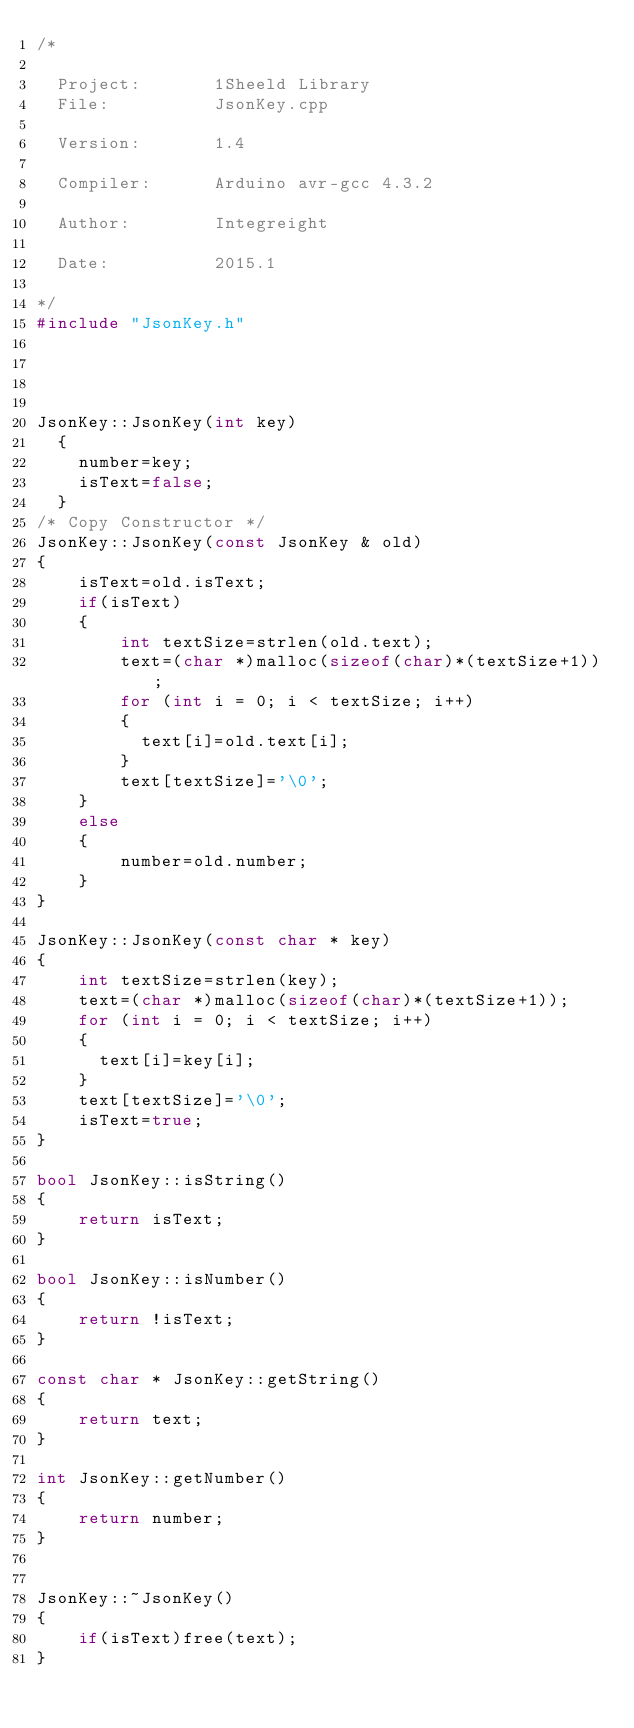Convert code to text. <code><loc_0><loc_0><loc_500><loc_500><_C++_>/*

  Project:       1Sheeld Library 
  File:          JsonKey.cpp
                 
  Version:       1.4

  Compiler:      Arduino avr-gcc 4.3.2

  Author:        Integreight
                 
  Date:          2015.1

*/
#include "JsonKey.h"




JsonKey::JsonKey(int key)
  {
    number=key;
    isText=false;
  }
/* Copy Constructor */
JsonKey::JsonKey(const JsonKey & old)
{
	isText=old.isText;
	if(isText)
	{
		int textSize=strlen(old.text);
		text=(char *)malloc(sizeof(char)*(textSize+1));
		for (int i = 0; i < textSize; i++)
		{
		  text[i]=old.text[i];
		}
		text[textSize]='\0';
	}
	else
	{
		number=old.number;
	}
}

JsonKey::JsonKey(const char * key)
{
	int textSize=strlen(key);
	text=(char *)malloc(sizeof(char)*(textSize+1));
	for (int i = 0; i < textSize; i++)
	{
	  text[i]=key[i];
	}
	text[textSize]='\0';
	isText=true;
}

bool JsonKey::isString()
{
    return isText;
}

bool JsonKey::isNumber()
{
    return !isText;
}

const char * JsonKey::getString()
{
    return text;
}

int JsonKey::getNumber()
{
    return number;
}


JsonKey::~JsonKey()
{
    if(isText)free(text);
}  </code> 